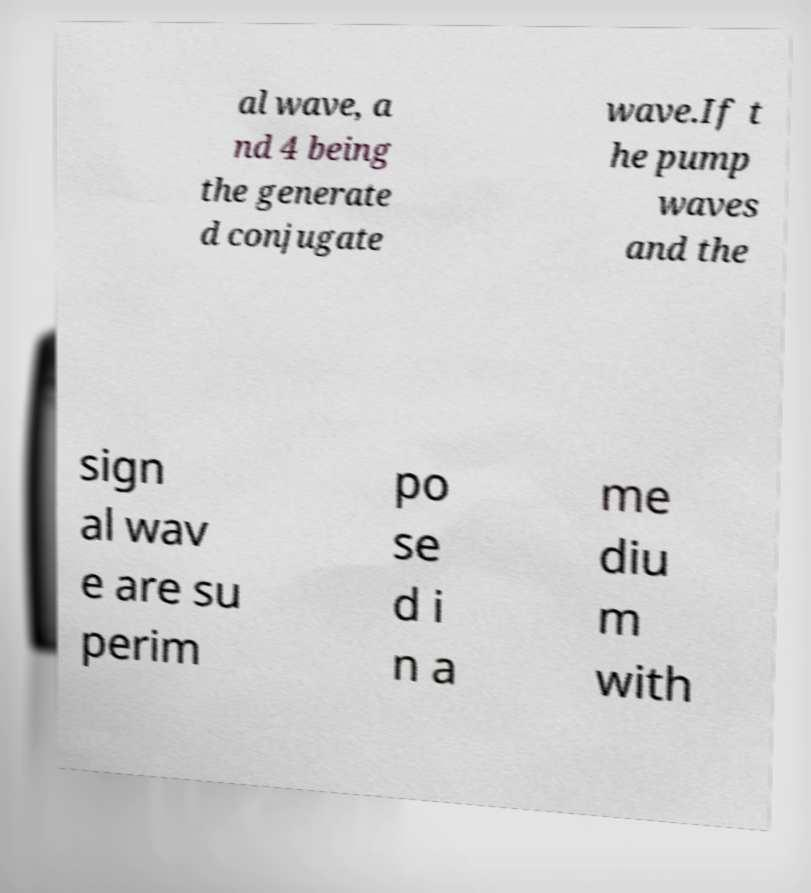I need the written content from this picture converted into text. Can you do that? al wave, a nd 4 being the generate d conjugate wave.If t he pump waves and the sign al wav e are su perim po se d i n a me diu m with 